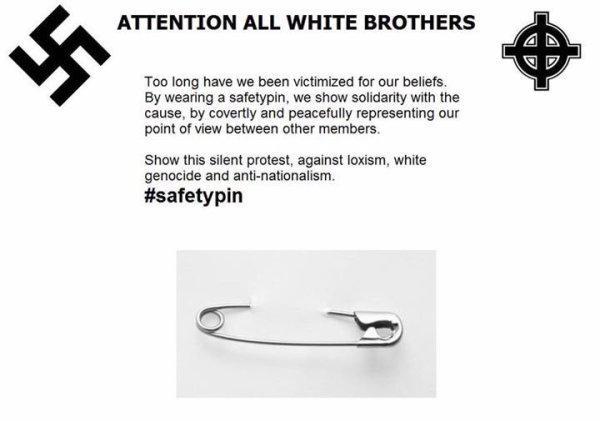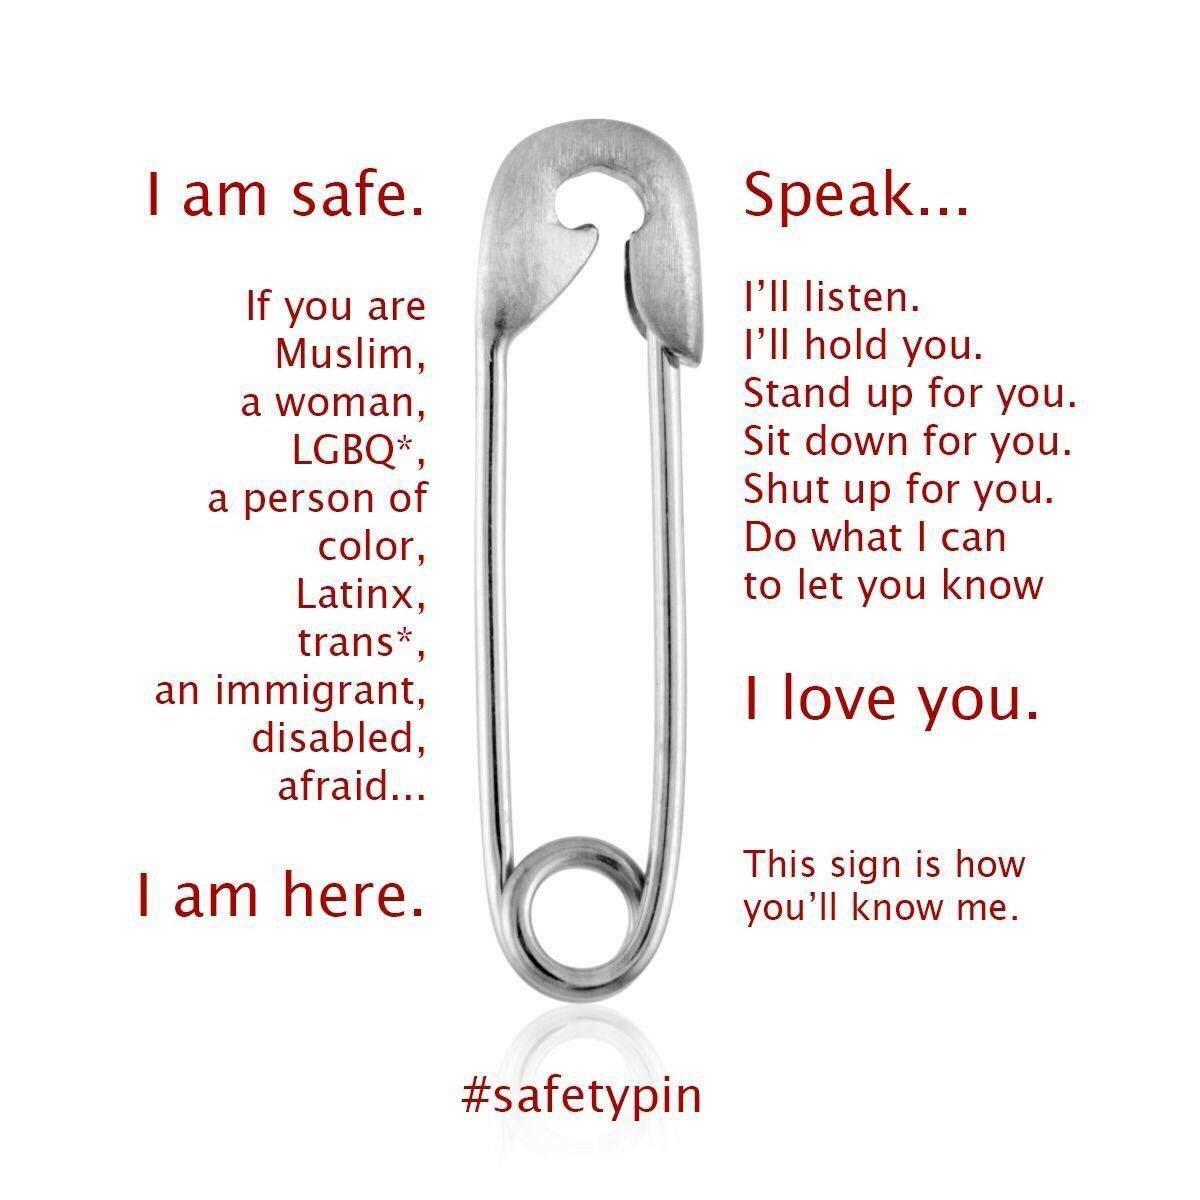The first image is the image on the left, the second image is the image on the right. Considering the images on both sides, is "There are more pins shown in the image on the left." valid? Answer yes or no. No. 